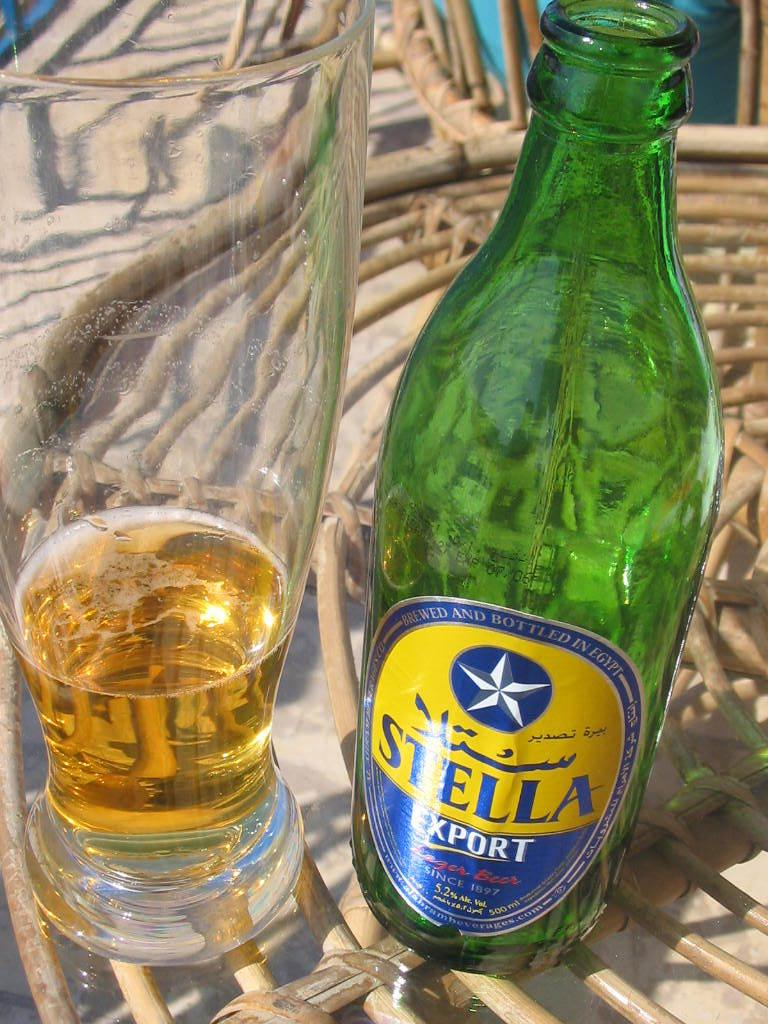<image>
Present a compact description of the photo's key features. Green beer bottle with a yellow label that says Stella. 